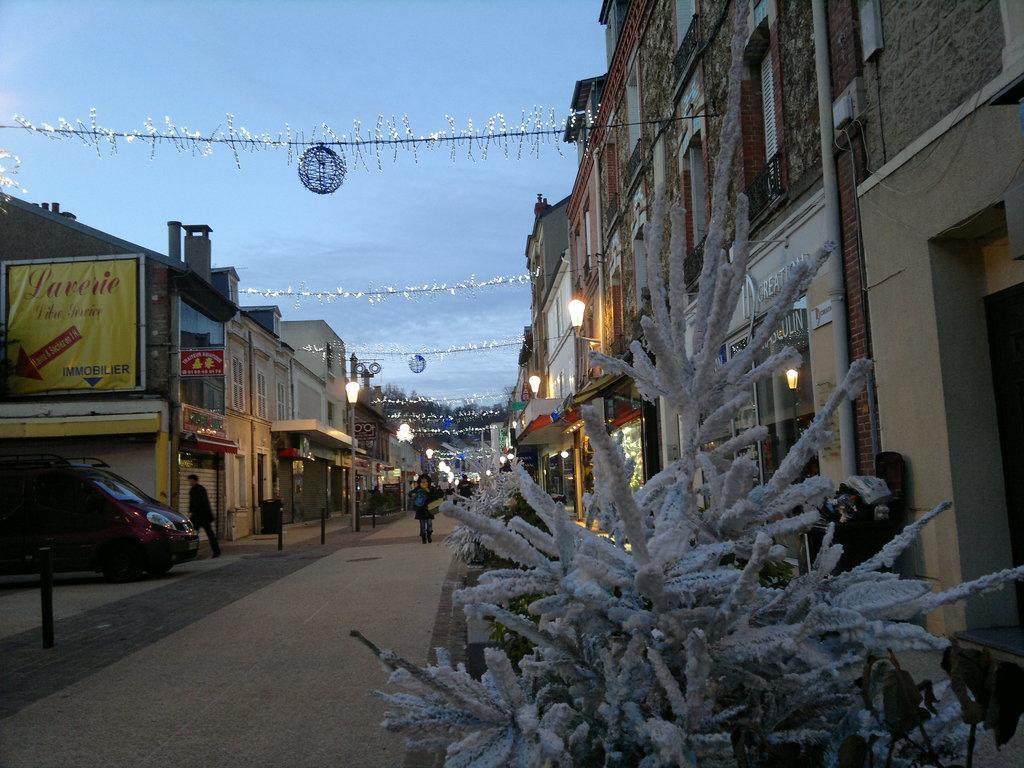Could you give a brief overview of what you see in this image? In this picture we can see few people, plants, metal rods and a vehicle, in the background we can find few buildings, hoardings, poles and lights. 